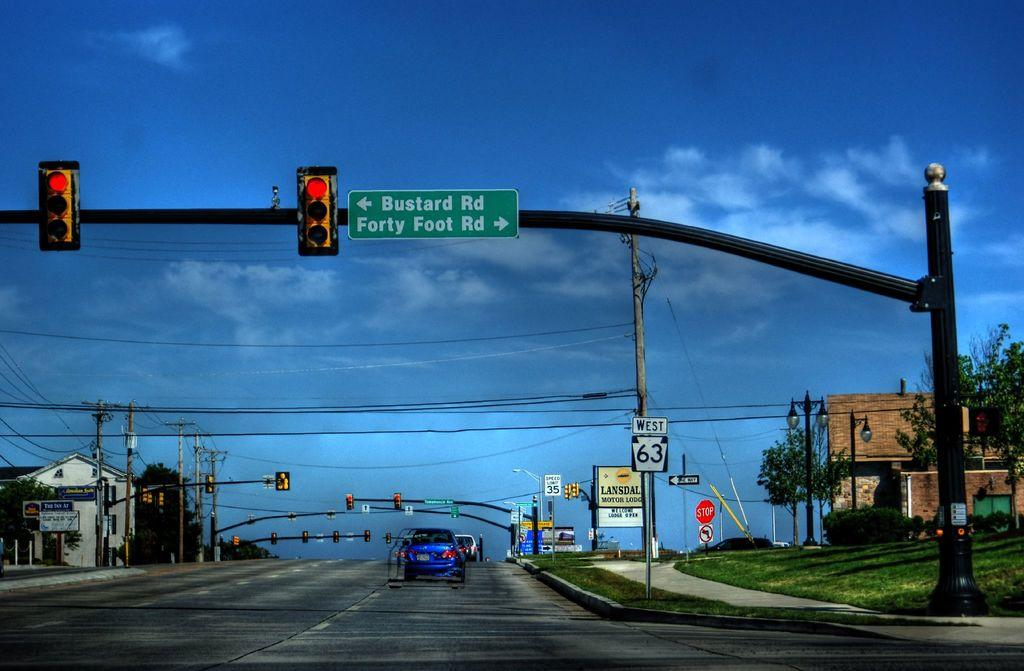<image>
Relay a brief, clear account of the picture shown. A large green and white road sign displayed above a highway that says Buster Rd and Forty Foot Rd. 